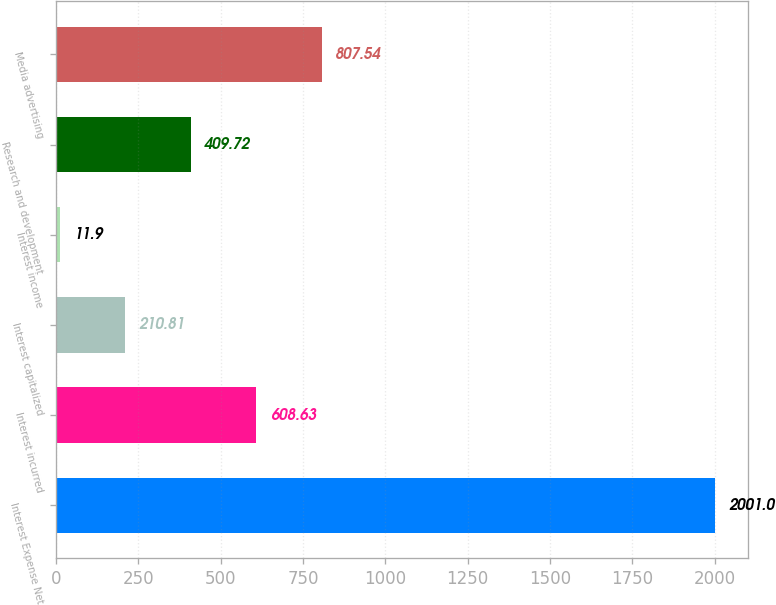Convert chart to OTSL. <chart><loc_0><loc_0><loc_500><loc_500><bar_chart><fcel>Interest Expense Net<fcel>Interest incurred<fcel>Interest capitalized<fcel>Interest income<fcel>Research and development<fcel>Media advertising<nl><fcel>2001<fcel>608.63<fcel>210.81<fcel>11.9<fcel>409.72<fcel>807.54<nl></chart> 